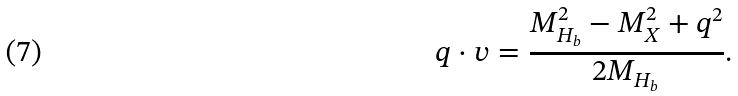Convert formula to latex. <formula><loc_0><loc_0><loc_500><loc_500>q \cdot v = { \frac { M _ { H _ { b } } ^ { 2 } - M _ { X } ^ { 2 } + q ^ { 2 } } { 2 M _ { H _ { b } } } } .</formula> 